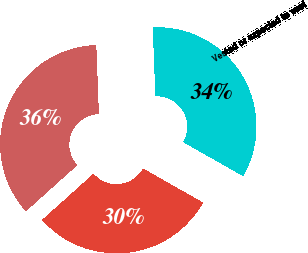<chart> <loc_0><loc_0><loc_500><loc_500><pie_chart><fcel>Outstanding<fcel>Vested or expected to vest<fcel>Exercisable<nl><fcel>36.04%<fcel>33.84%<fcel>30.12%<nl></chart> 